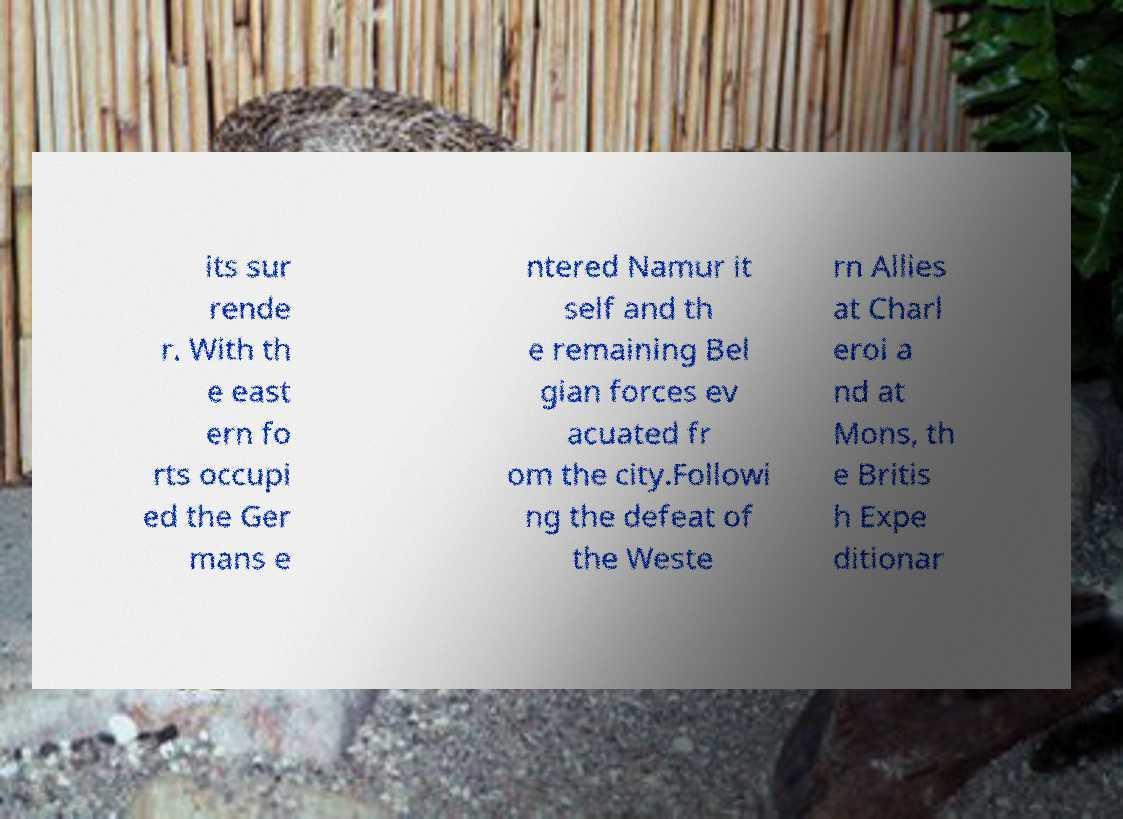Can you accurately transcribe the text from the provided image for me? its sur rende r. With th e east ern fo rts occupi ed the Ger mans e ntered Namur it self and th e remaining Bel gian forces ev acuated fr om the city.Followi ng the defeat of the Weste rn Allies at Charl eroi a nd at Mons, th e Britis h Expe ditionar 